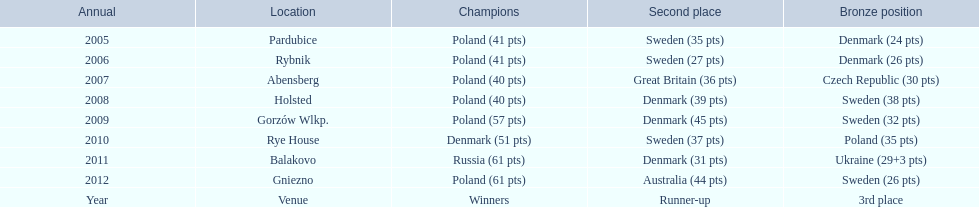After their first place win in 2009, how did poland place the next year at the speedway junior world championship? 3rd place. 